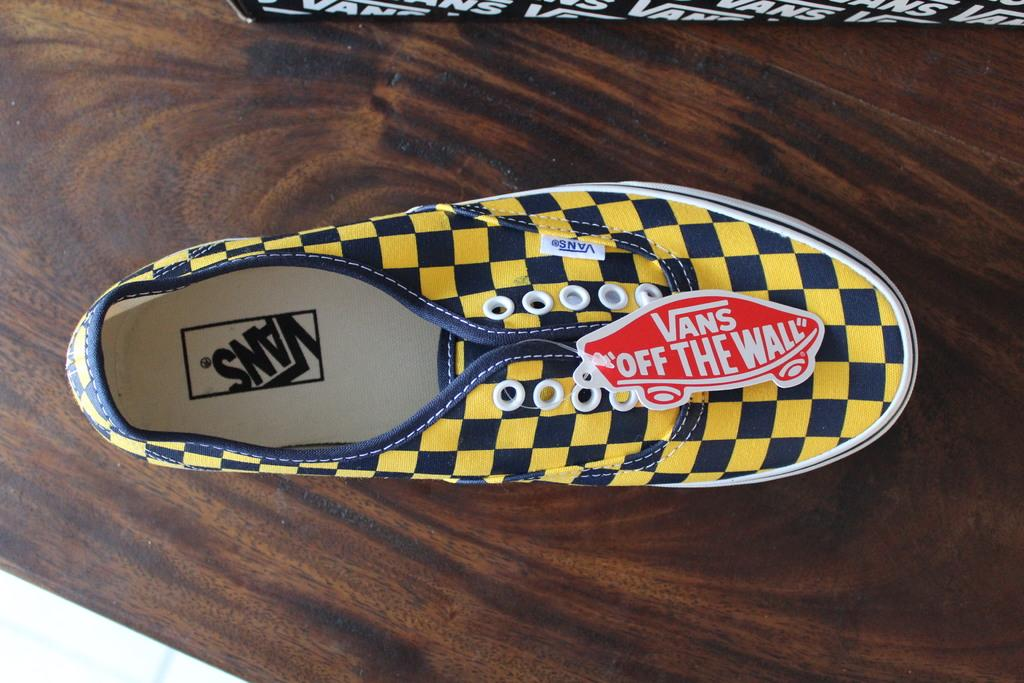What object is in the image? There is a shoe in the image. What is the shoe placed on? The shoe is on a wooden surface. What can be seen on the shoe itself? There is text on the shoe. Is there any additional information attached to the shoe? Yes, there is a label with text attached to the shoe. What else can be seen at the top of the image? There is text on a box at the top of the image. Can you see any grass growing around the shoe in the image? No, there is no grass visible in the image; the shoe is placed on a wooden surface. Is there a cast on the shoe in the image? No, there is no cast present on the shoe in the image. 